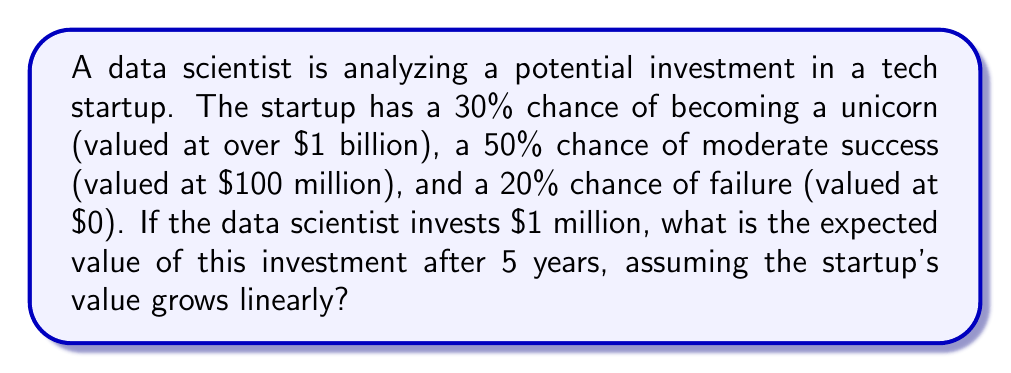Can you answer this question? To calculate the expected value of this investment, we need to use probability theory and the concept of expected value. Let's break it down step-by-step:

1. Define the possible outcomes and their probabilities:
   - Unicorn: $p_1 = 0.30$, $v_1 = \$1,000,000,000$
   - Moderate success: $p_2 = 0.50$, $v_2 = \$100,000,000$
   - Failure: $p_3 = 0.20$, $v_3 = \$0$

2. Calculate the expected value of the startup after 5 years:
   $$E[V] = p_1v_1 + p_2v_2 + p_3v_3$$
   $$E[V] = 0.30 \cdot \$1,000,000,000 + 0.50 \cdot \$100,000,000 + 0.20 \cdot \$0$$
   $$E[V] = \$300,000,000 + \$50,000,000 + \$0 = \$350,000,000$$

3. Calculate the expected return on investment (ROI):
   $$\text{Expected ROI} = \frac{E[V] - \text{Initial Investment}}{\text{Initial Investment}}$$
   $$\text{Expected ROI} = \frac{\$350,000,000 - \$1,000,000}{\$1,000,000} = 349$$

4. Calculate the expected value of the investment after 5 years:
   $$\text{Expected Value} = \text{Initial Investment} \cdot (1 + \text{Expected ROI})$$
   $$\text{Expected Value} = \$1,000,000 \cdot (1 + 349) = \$350,000,000$$

This result shows that the expected value of the $1 million investment after 5 years is $350 million, which is consistent with the expected value of the startup we calculated earlier.
Answer: The expected value of the $1 million investment after 5 years is $350,000,000. 